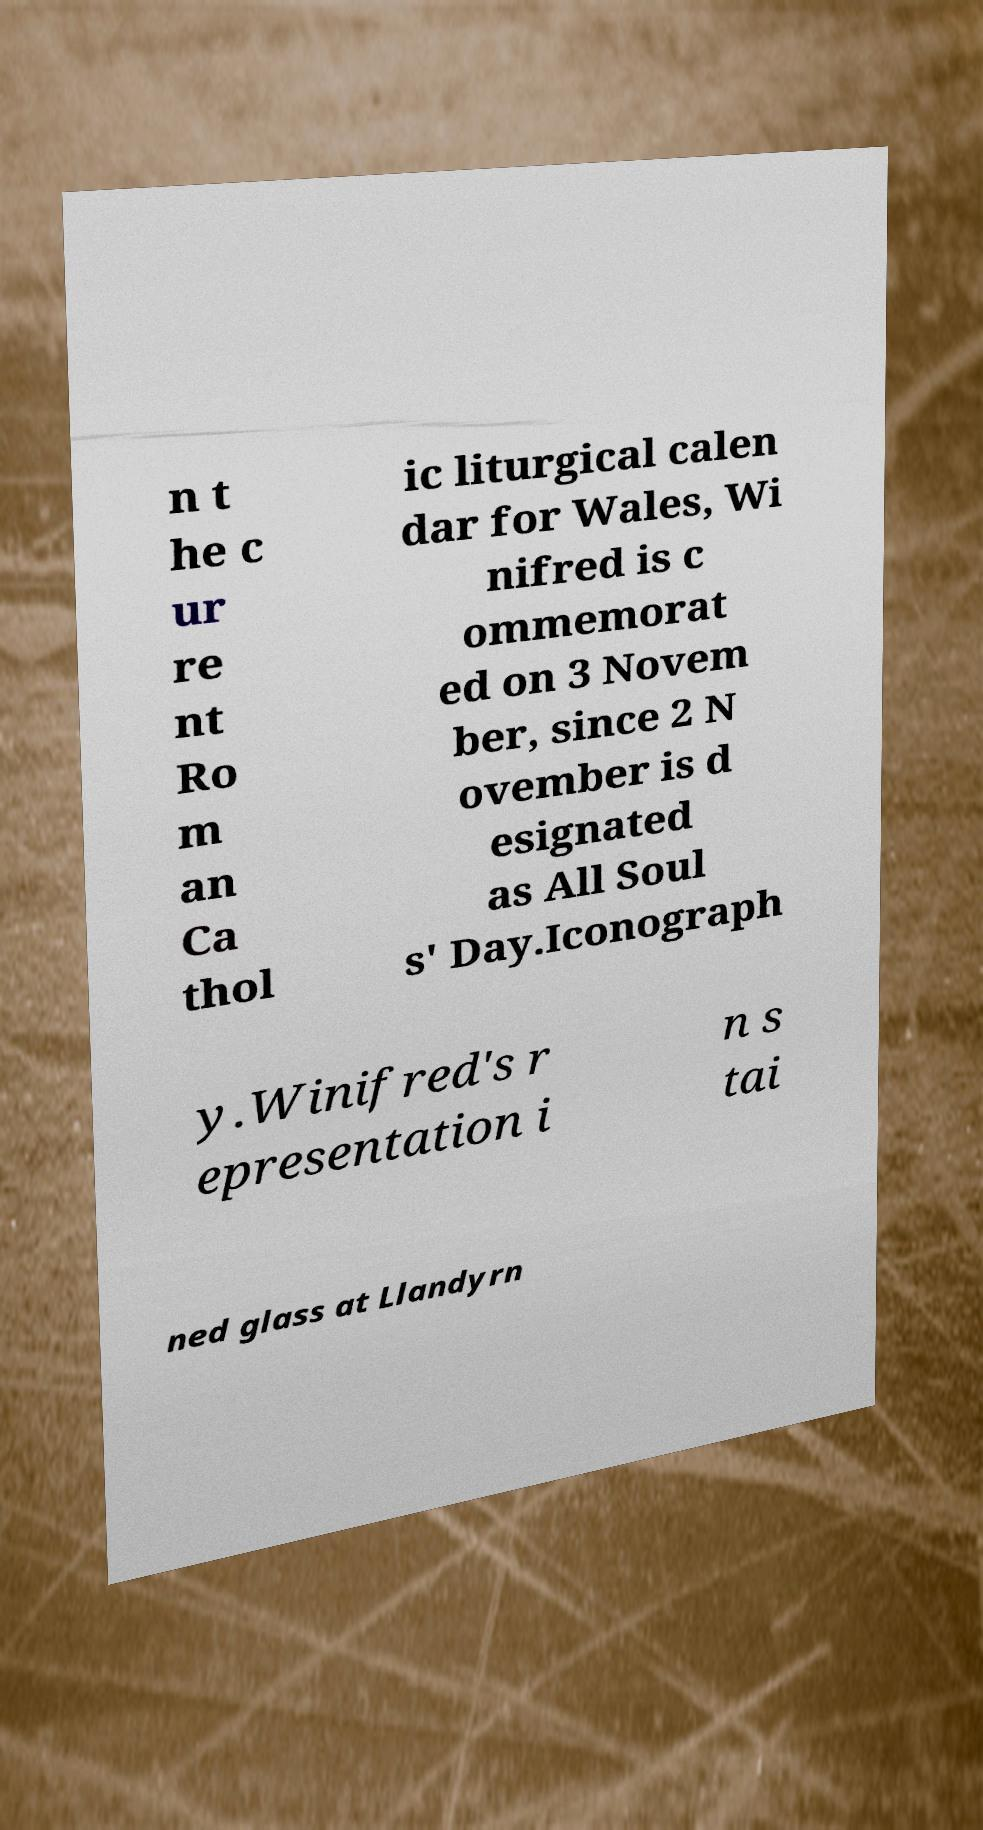Could you assist in decoding the text presented in this image and type it out clearly? n t he c ur re nt Ro m an Ca thol ic liturgical calen dar for Wales, Wi nifred is c ommemorat ed on 3 Novem ber, since 2 N ovember is d esignated as All Soul s' Day.Iconograph y.Winifred's r epresentation i n s tai ned glass at Llandyrn 